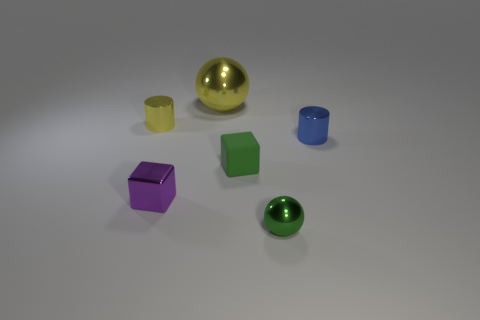Add 1 small yellow cylinders. How many objects exist? 7 Subtract all spheres. How many objects are left? 4 Subtract all small shiny cylinders. Subtract all small purple cylinders. How many objects are left? 4 Add 2 yellow metallic balls. How many yellow metallic balls are left? 3 Add 6 shiny spheres. How many shiny spheres exist? 8 Subtract 1 yellow cylinders. How many objects are left? 5 